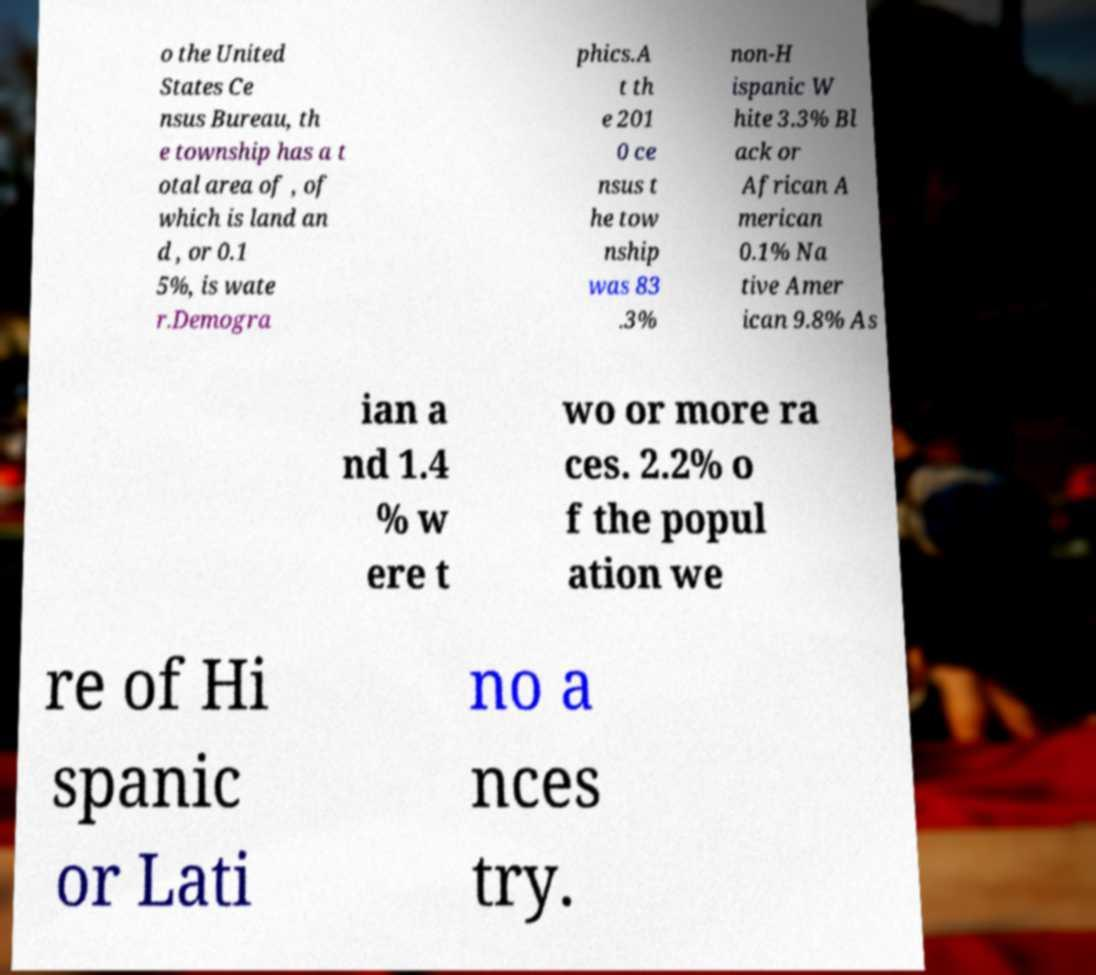Could you assist in decoding the text presented in this image and type it out clearly? o the United States Ce nsus Bureau, th e township has a t otal area of , of which is land an d , or 0.1 5%, is wate r.Demogra phics.A t th e 201 0 ce nsus t he tow nship was 83 .3% non-H ispanic W hite 3.3% Bl ack or African A merican 0.1% Na tive Amer ican 9.8% As ian a nd 1.4 % w ere t wo or more ra ces. 2.2% o f the popul ation we re of Hi spanic or Lati no a nces try. 